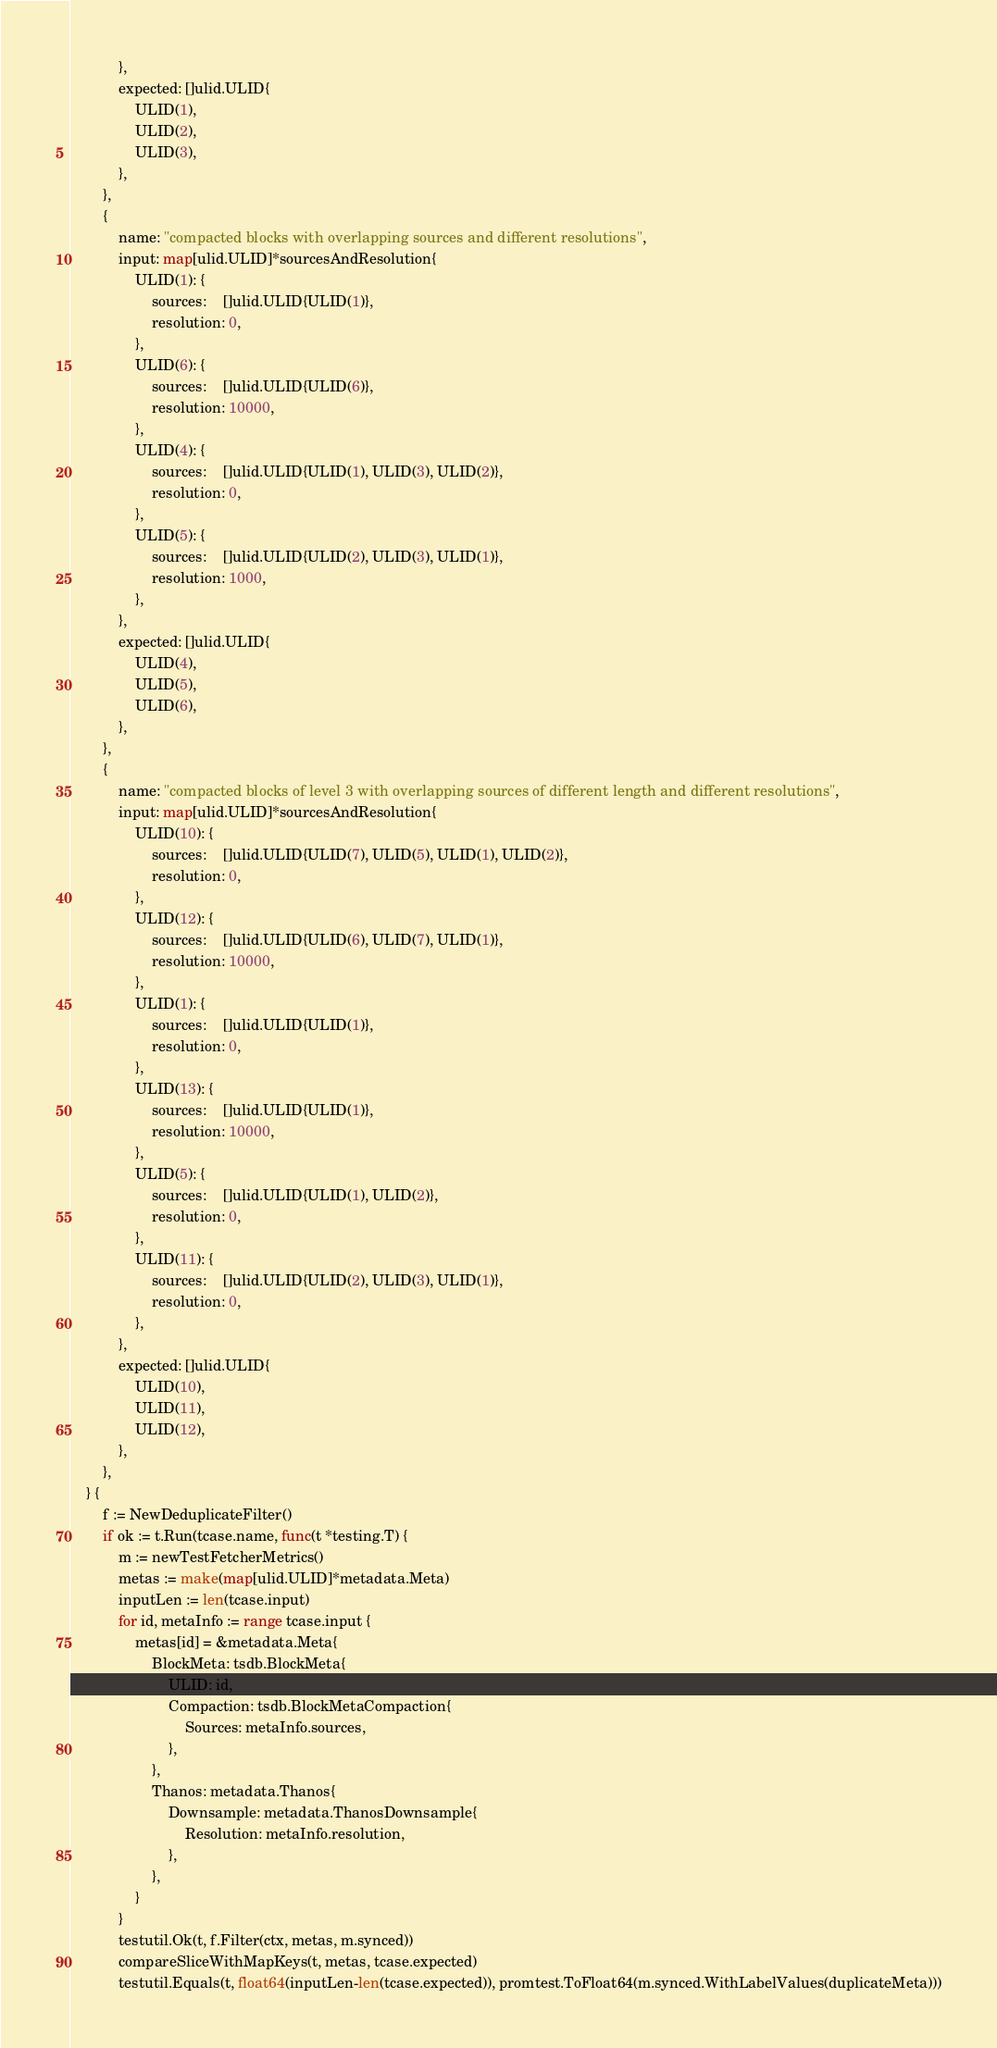Convert code to text. <code><loc_0><loc_0><loc_500><loc_500><_Go_>			},
			expected: []ulid.ULID{
				ULID(1),
				ULID(2),
				ULID(3),
			},
		},
		{
			name: "compacted blocks with overlapping sources and different resolutions",
			input: map[ulid.ULID]*sourcesAndResolution{
				ULID(1): {
					sources:    []ulid.ULID{ULID(1)},
					resolution: 0,
				},
				ULID(6): {
					sources:    []ulid.ULID{ULID(6)},
					resolution: 10000,
				},
				ULID(4): {
					sources:    []ulid.ULID{ULID(1), ULID(3), ULID(2)},
					resolution: 0,
				},
				ULID(5): {
					sources:    []ulid.ULID{ULID(2), ULID(3), ULID(1)},
					resolution: 1000,
				},
			},
			expected: []ulid.ULID{
				ULID(4),
				ULID(5),
				ULID(6),
			},
		},
		{
			name: "compacted blocks of level 3 with overlapping sources of different length and different resolutions",
			input: map[ulid.ULID]*sourcesAndResolution{
				ULID(10): {
					sources:    []ulid.ULID{ULID(7), ULID(5), ULID(1), ULID(2)},
					resolution: 0,
				},
				ULID(12): {
					sources:    []ulid.ULID{ULID(6), ULID(7), ULID(1)},
					resolution: 10000,
				},
				ULID(1): {
					sources:    []ulid.ULID{ULID(1)},
					resolution: 0,
				},
				ULID(13): {
					sources:    []ulid.ULID{ULID(1)},
					resolution: 10000,
				},
				ULID(5): {
					sources:    []ulid.ULID{ULID(1), ULID(2)},
					resolution: 0,
				},
				ULID(11): {
					sources:    []ulid.ULID{ULID(2), ULID(3), ULID(1)},
					resolution: 0,
				},
			},
			expected: []ulid.ULID{
				ULID(10),
				ULID(11),
				ULID(12),
			},
		},
	} {
		f := NewDeduplicateFilter()
		if ok := t.Run(tcase.name, func(t *testing.T) {
			m := newTestFetcherMetrics()
			metas := make(map[ulid.ULID]*metadata.Meta)
			inputLen := len(tcase.input)
			for id, metaInfo := range tcase.input {
				metas[id] = &metadata.Meta{
					BlockMeta: tsdb.BlockMeta{
						ULID: id,
						Compaction: tsdb.BlockMetaCompaction{
							Sources: metaInfo.sources,
						},
					},
					Thanos: metadata.Thanos{
						Downsample: metadata.ThanosDownsample{
							Resolution: metaInfo.resolution,
						},
					},
				}
			}
			testutil.Ok(t, f.Filter(ctx, metas, m.synced))
			compareSliceWithMapKeys(t, metas, tcase.expected)
			testutil.Equals(t, float64(inputLen-len(tcase.expected)), promtest.ToFloat64(m.synced.WithLabelValues(duplicateMeta)))</code> 